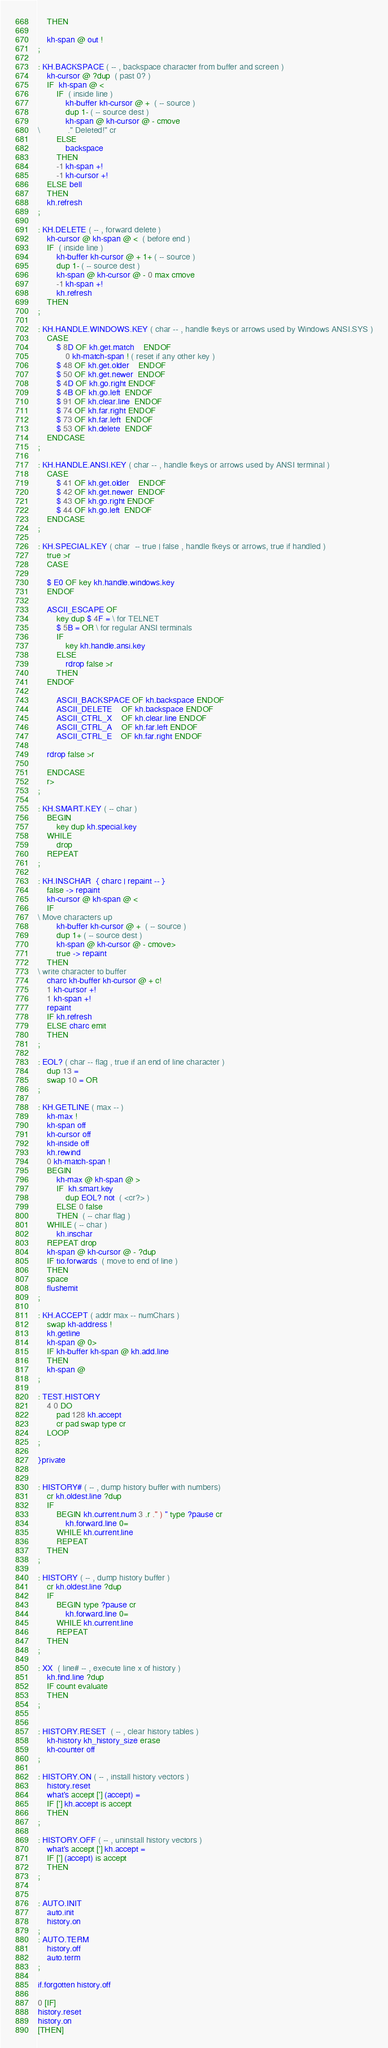Convert code to text. <code><loc_0><loc_0><loc_500><loc_500><_Forth_>    THEN

    kh-span @ out !
;

: KH.BACKSPACE ( -- , backspace character from buffer and screen )
    kh-cursor @ ?dup  ( past 0? )
    IF  kh-span @ <
        IF  ( inside line )
            kh-buffer kh-cursor @ +  ( -- source )
            dup 1- ( -- source dest )
            kh-span @ kh-cursor @ - cmove
\            ." Deleted!" cr
        ELSE
            backspace
        THEN
        -1 kh-span +!
        -1 kh-cursor +!
    ELSE bell
    THEN
    kh.refresh
;

: KH.DELETE ( -- , forward delete )
    kh-cursor @ kh-span @ <  ( before end )
    IF  ( inside line )
        kh-buffer kh-cursor @ + 1+ ( -- source )
        dup 1- ( -- source dest )
        kh-span @ kh-cursor @ - 0 max cmove
        -1 kh-span +!
        kh.refresh
    THEN
;

: KH.HANDLE.WINDOWS.KEY ( char -- , handle fkeys or arrows used by Windows ANSI.SYS )
    CASE
        $ 8D OF kh.get.match    ENDOF
            0 kh-match-span ! ( reset if any other key )
        $ 48 OF kh.get.older    ENDOF
        $ 50 OF kh.get.newer  ENDOF
        $ 4D OF kh.go.right ENDOF
        $ 4B OF kh.go.left  ENDOF
        $ 91 OF kh.clear.line  ENDOF
        $ 74 OF kh.far.right ENDOF
        $ 73 OF kh.far.left  ENDOF
        $ 53 OF kh.delete  ENDOF
    ENDCASE
;

: KH.HANDLE.ANSI.KEY ( char -- , handle fkeys or arrows used by ANSI terminal )
    CASE
        $ 41 OF kh.get.older    ENDOF
        $ 42 OF kh.get.newer  ENDOF
        $ 43 OF kh.go.right ENDOF
        $ 44 OF kh.go.left  ENDOF
    ENDCASE
;

: KH.SPECIAL.KEY ( char  -- true | false , handle fkeys or arrows, true if handled )
    true >r
    CASE

    $ E0 OF key kh.handle.windows.key
    ENDOF

    ASCII_ESCAPE OF
        key dup $ 4F = \ for TELNET
        $ 5B = OR \ for regular ANSI terminals
        IF
            key kh.handle.ansi.key
        ELSE
            rdrop false >r
        THEN
    ENDOF

        ASCII_BACKSPACE OF kh.backspace ENDOF
        ASCII_DELETE    OF kh.backspace ENDOF
        ASCII_CTRL_X    OF kh.clear.line ENDOF
        ASCII_CTRL_A    OF kh.far.left ENDOF
        ASCII_CTRL_E    OF kh.far.right ENDOF

    rdrop false >r

    ENDCASE
    r>
;

: KH.SMART.KEY ( -- char )
    BEGIN
        key dup kh.special.key
    WHILE
        drop
    REPEAT
;

: KH.INSCHAR  { charc | repaint -- }
    false -> repaint
    kh-cursor @ kh-span @ <
    IF
\ Move characters up
        kh-buffer kh-cursor @ +  ( -- source )
        dup 1+ ( -- source dest )
        kh-span @ kh-cursor @ - cmove>
        true -> repaint
    THEN
\ write character to buffer
    charc kh-buffer kh-cursor @ + c!
    1 kh-cursor +!
    1 kh-span +!
    repaint
    IF kh.refresh
    ELSE charc emit
    THEN
;

: EOL? ( char -- flag , true if an end of line character )
    dup 13 =
    swap 10 = OR
;

: KH.GETLINE ( max -- )
    kh-max !
    kh-span off
    kh-cursor off
    kh-inside off
    kh.rewind
    0 kh-match-span !
    BEGIN
        kh-max @ kh-span @ >
        IF  kh.smart.key
            dup EOL? not  ( <cr?> )
        ELSE 0 false
        THEN  ( -- char flag )
    WHILE ( -- char )
        kh.inschar
    REPEAT drop
    kh-span @ kh-cursor @ - ?dup
    IF tio.forwards  ( move to end of line )
    THEN
    space
    flushemit
;

: KH.ACCEPT ( addr max -- numChars )
    swap kh-address !
    kh.getline
    kh-span @ 0>
    IF kh-buffer kh-span @ kh.add.line
    THEN
    kh-span @
;

: TEST.HISTORY
    4 0 DO
        pad 128 kh.accept
        cr pad swap type cr
    LOOP
;

}private


: HISTORY# ( -- , dump history buffer with numbers)
    cr kh.oldest.line ?dup
    IF
        BEGIN kh.current.num 3 .r ." ) " type ?pause cr
            kh.forward.line 0=
        WHILE kh.current.line
        REPEAT
    THEN
;

: HISTORY ( -- , dump history buffer )
    cr kh.oldest.line ?dup
    IF
        BEGIN type ?pause cr
            kh.forward.line 0=
        WHILE kh.current.line
        REPEAT
    THEN
;

: XX  ( line# -- , execute line x of history )
    kh.find.line ?dup
    IF count evaluate
    THEN
;


: HISTORY.RESET  ( -- , clear history tables )
    kh-history kh_history_size erase
    kh-counter off
;

: HISTORY.ON ( -- , install history vectors )
    history.reset
    what's accept ['] (accept) =
    IF ['] kh.accept is accept
    THEN
;

: HISTORY.OFF ( -- , uninstall history vectors )
    what's accept ['] kh.accept =
    IF ['] (accept) is accept
    THEN
;


: AUTO.INIT
    auto.init
    history.on
;
: AUTO.TERM
    history.off
    auto.term
;

if.forgotten history.off

0 [IF]
history.reset
history.on
[THEN]
</code> 